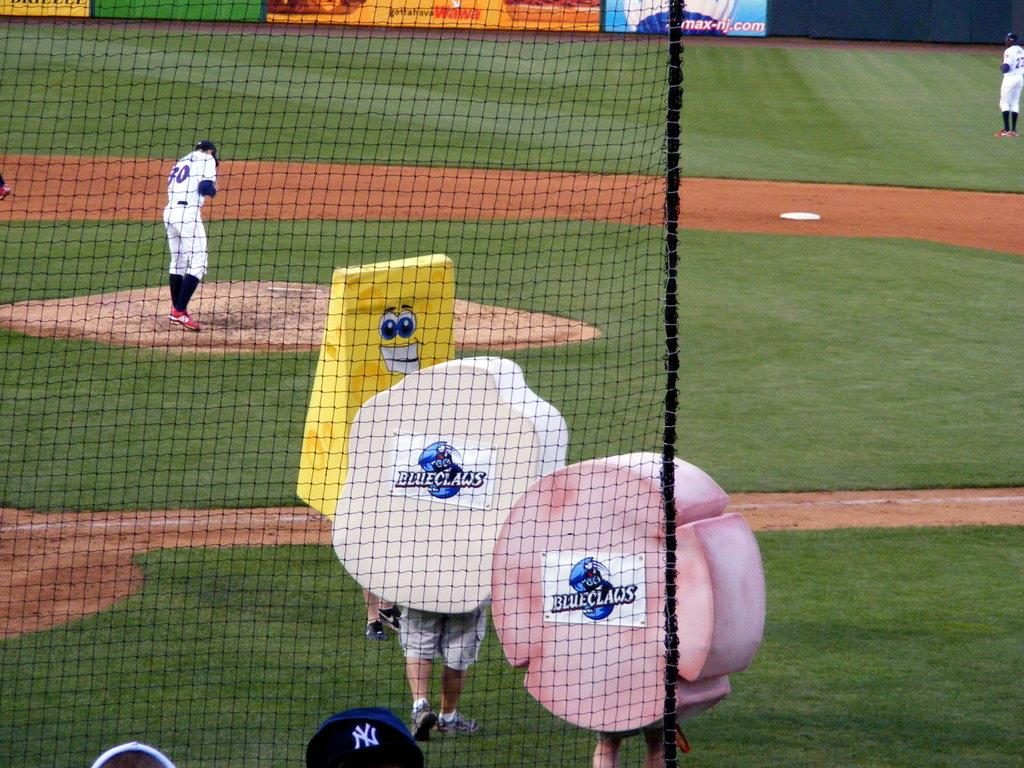<image>
Summarize the visual content of the image. Two blueclaws and a large wedge of cheese are on the baseball field. 